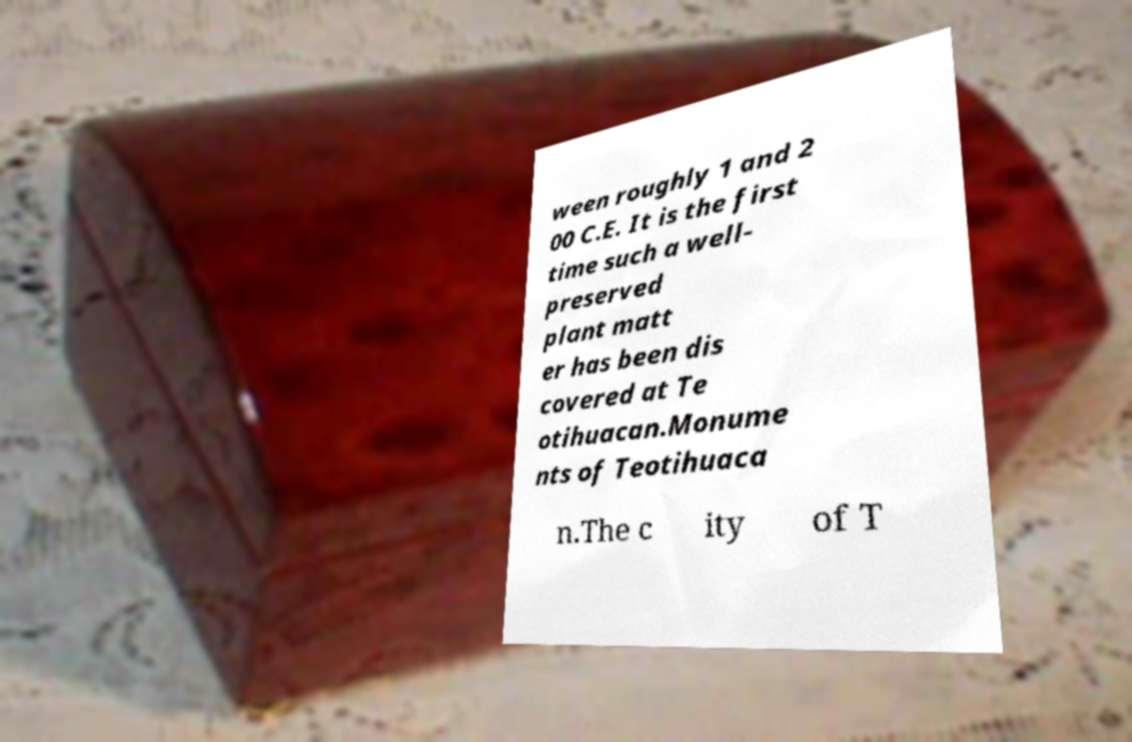I need the written content from this picture converted into text. Can you do that? ween roughly 1 and 2 00 C.E. It is the first time such a well- preserved plant matt er has been dis covered at Te otihuacan.Monume nts of Teotihuaca n.The c ity of T 